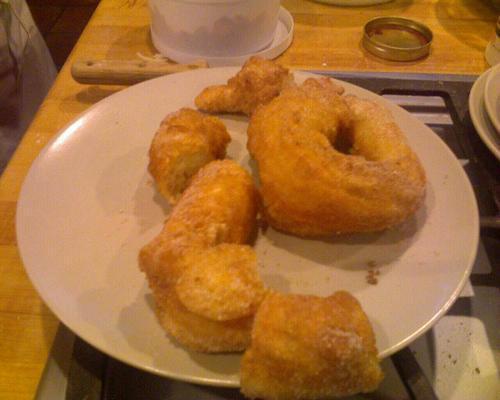How many lids are shown?
Give a very brief answer. 2. 